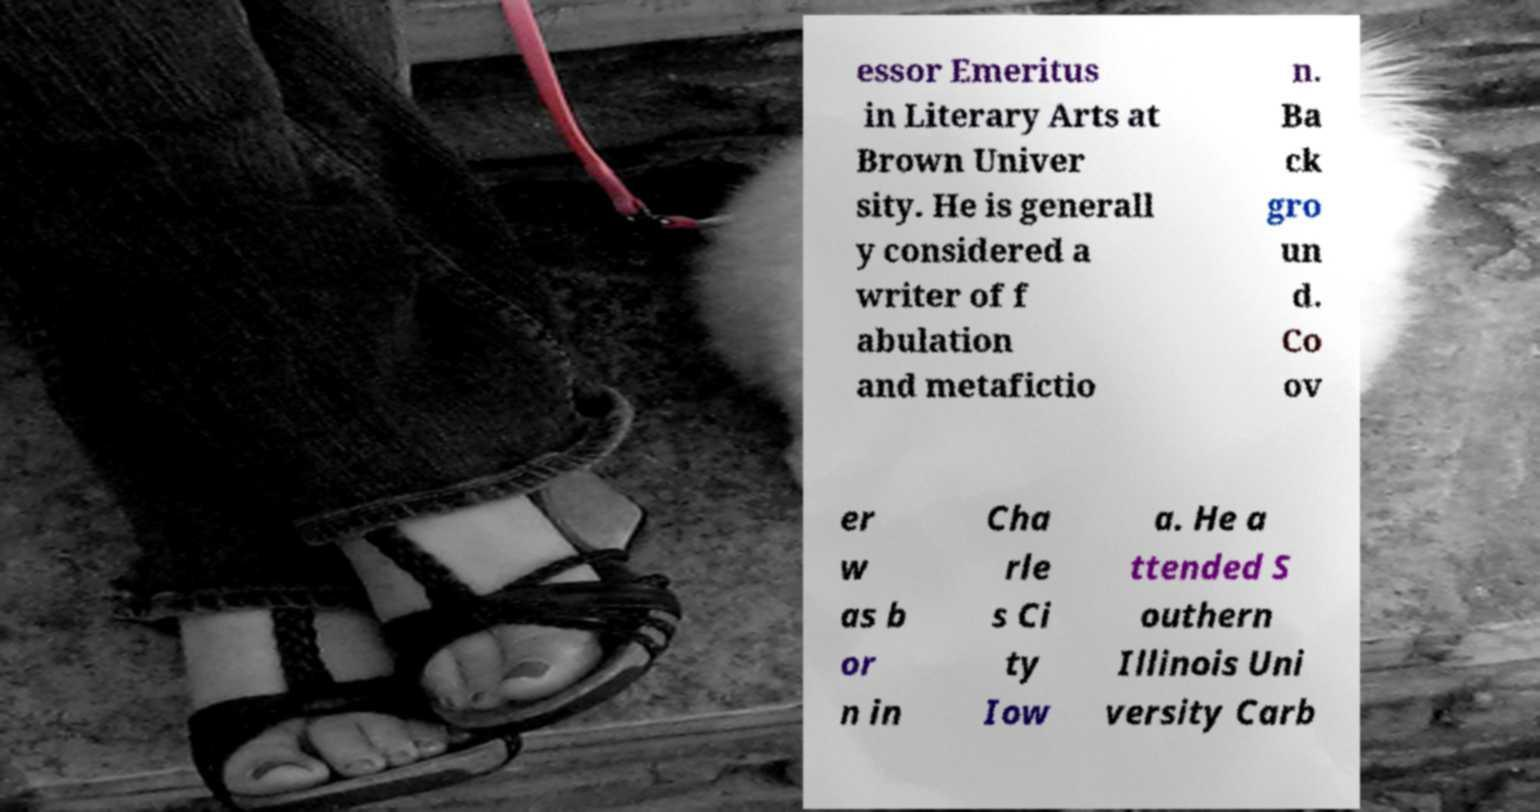For documentation purposes, I need the text within this image transcribed. Could you provide that? essor Emeritus in Literary Arts at Brown Univer sity. He is generall y considered a writer of f abulation and metafictio n. Ba ck gro un d. Co ov er w as b or n in Cha rle s Ci ty Iow a. He a ttended S outhern Illinois Uni versity Carb 